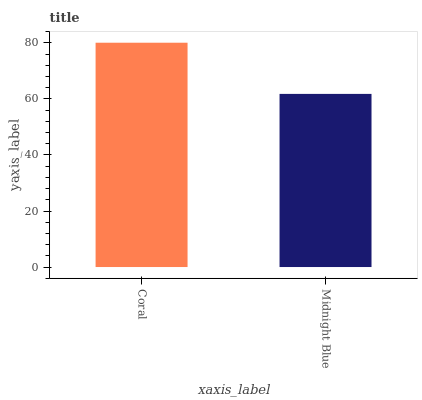Is Midnight Blue the maximum?
Answer yes or no. No. Is Coral greater than Midnight Blue?
Answer yes or no. Yes. Is Midnight Blue less than Coral?
Answer yes or no. Yes. Is Midnight Blue greater than Coral?
Answer yes or no. No. Is Coral less than Midnight Blue?
Answer yes or no. No. Is Coral the high median?
Answer yes or no. Yes. Is Midnight Blue the low median?
Answer yes or no. Yes. Is Midnight Blue the high median?
Answer yes or no. No. Is Coral the low median?
Answer yes or no. No. 